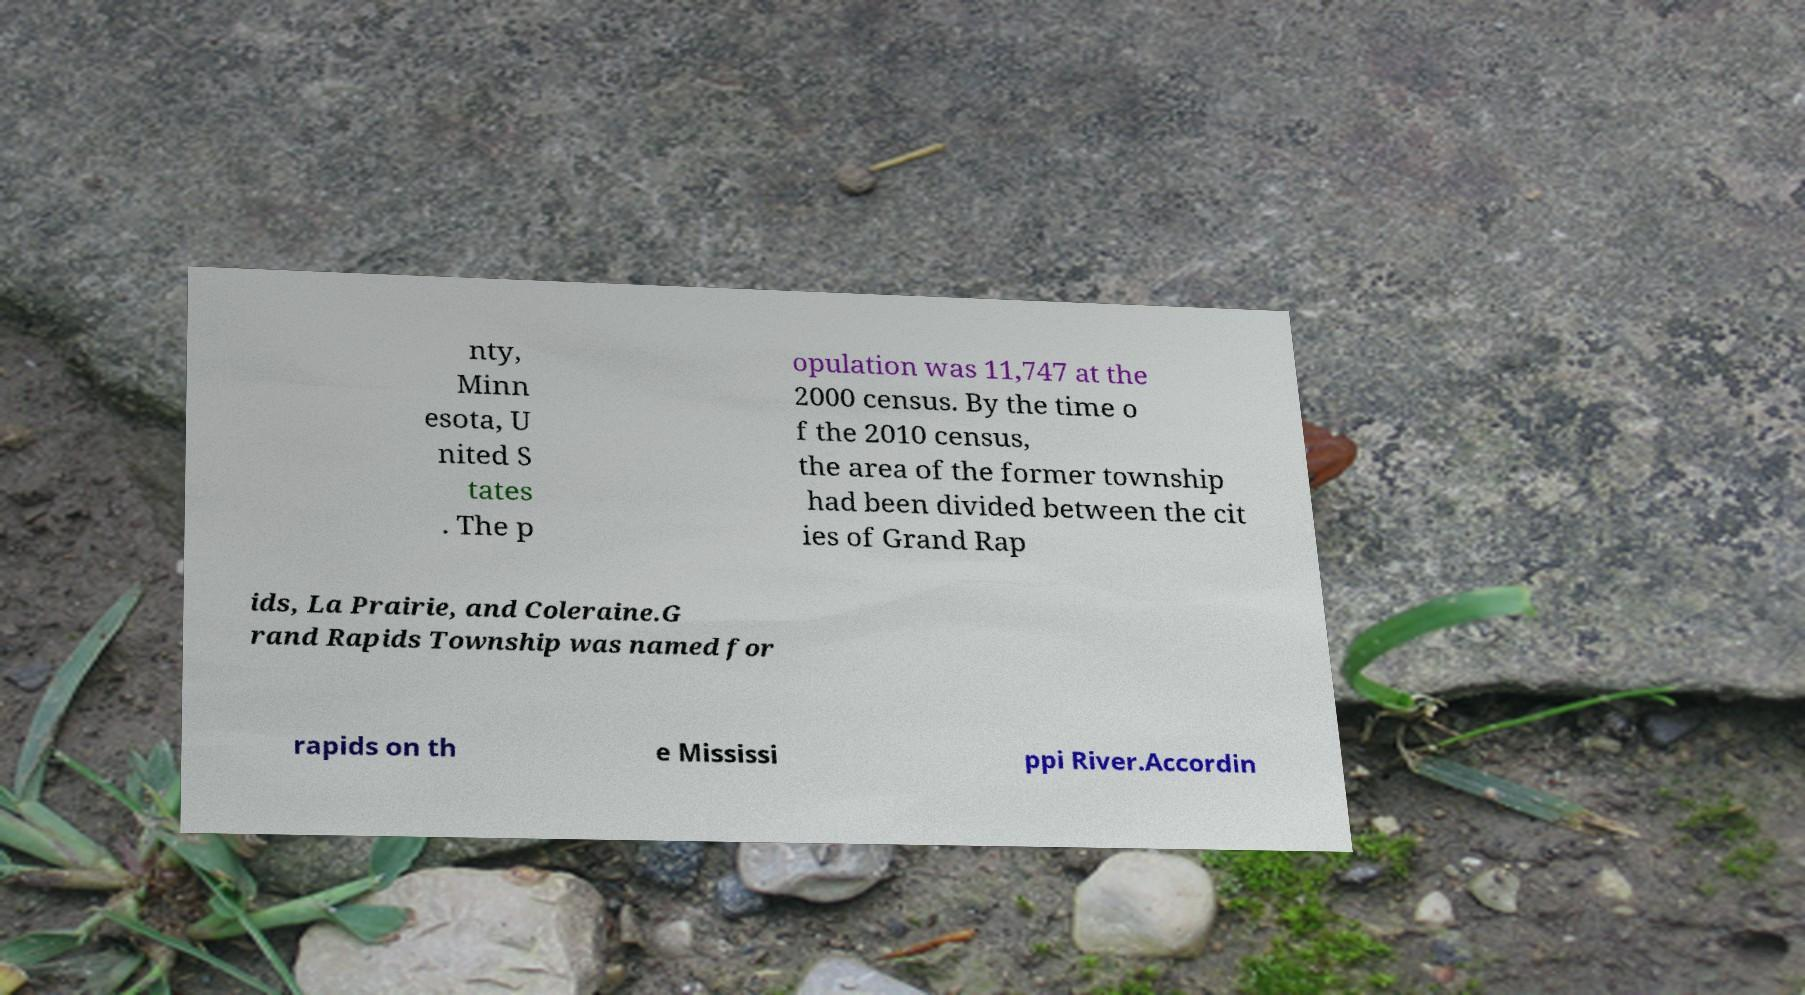Can you read and provide the text displayed in the image?This photo seems to have some interesting text. Can you extract and type it out for me? nty, Minn esota, U nited S tates . The p opulation was 11,747 at the 2000 census. By the time o f the 2010 census, the area of the former township had been divided between the cit ies of Grand Rap ids, La Prairie, and Coleraine.G rand Rapids Township was named for rapids on th e Mississi ppi River.Accordin 